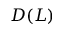<formula> <loc_0><loc_0><loc_500><loc_500>D ( L )</formula> 